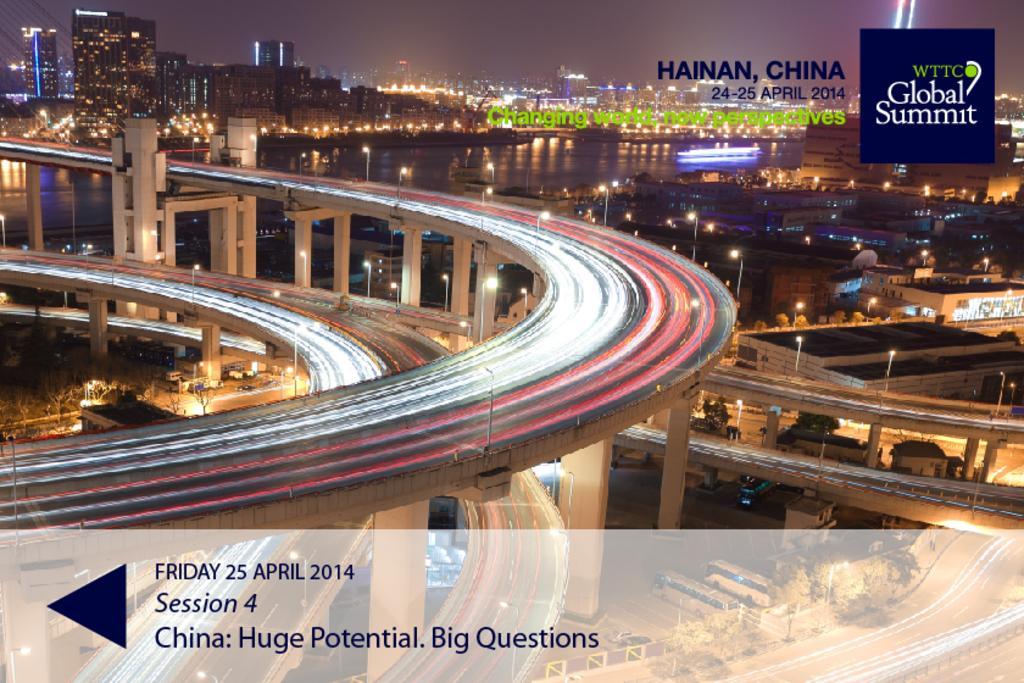In one or two sentences, can you explain what this image depicts? As we can see in the image there is a road, buildings, lights and sky. The image is little dark. Here there is water and boat. 